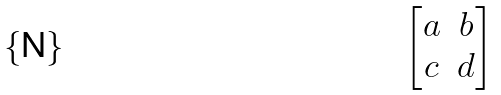<formula> <loc_0><loc_0><loc_500><loc_500>\begin{bmatrix} { a } & { b } \\ { c } & { d } \end{bmatrix}</formula> 